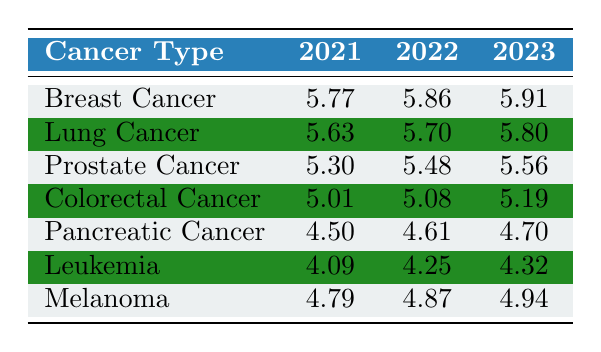What's the number of clinical trials for Breast Cancer in 2023? According to the table, the value for Breast Cancer in 2023 is listed as 5.91.
Answer: 5.91 Which cancer type has the highest number of clinical trials in 2022? From the table, we see that Breast Cancer has 5.86, which is higher than any other cancer type in that year.
Answer: Breast Cancer What is the difference in the number of clinical trials for Lung Cancer between 2021 and 2022? To find the difference, subtract the number for 2021 (5.63) from the number for 2022 (5.70): 5.70 - 5.63 = 0.07.
Answer: 0.07 Was there an increase in the number of clinical trials for Prostate Cancer from 2021 to 2023? Yes, the value increased from 5.30 in 2021 to 5.56 in 2023, indicating a positive change over time.
Answer: Yes What is the average number of clinical trials for Colorectal Cancer over the three years? Add the values across the three years: (5.01 + 5.08 + 5.19) = 15.28. Then, divide by 3 to find the average: 15.28 / 3 = 5.09.
Answer: 5.09 How many more clinical trials were available for Melanoma in 2023 compared to 2021? The value for Melanoma in 2023 is 4.94 and in 2021 is 4.79. So, we subtract: 4.94 - 4.79 = 0.15.
Answer: 0.15 Is the number of trials for Leukemia in 2022 higher than that for Pancreatic Cancer in the same year? Yes, Leukemia has 4.25 in 2022 while Pancreatic Cancer has 4.61, indicating that Leukemia has a lower number of trials than Pancreatic Cancer.
Answer: No What is the total number of clinical trials for all types of cancer in 2021? We sum the values for all cancer types in 2021: (5.77 + 5.63 + 5.30 + 5.01 + 4.50 + 4.09 + 4.79) = 35.09.
Answer: 35.09 Which cancer type showed the least increase in the number of trials from 2021 to 2023? By calculating the increases: Breast Cancer (0.14), Lung Cancer (0.17), Prostate Cancer (0.26), Colorectal Cancer (0.18), Pancreatic Cancer (0.20), Leukemia (0.23), and Melanoma (0.15). Melanoma showed the least increase.
Answer: Melanoma What was the total count of trials for both Lung Cancer and Breast Cancer in 2022? To find this, add the trials for Lung Cancer (5.70) to those for Breast Cancer (5.86): 5.70 + 5.86 = 11.56.
Answer: 11.56 